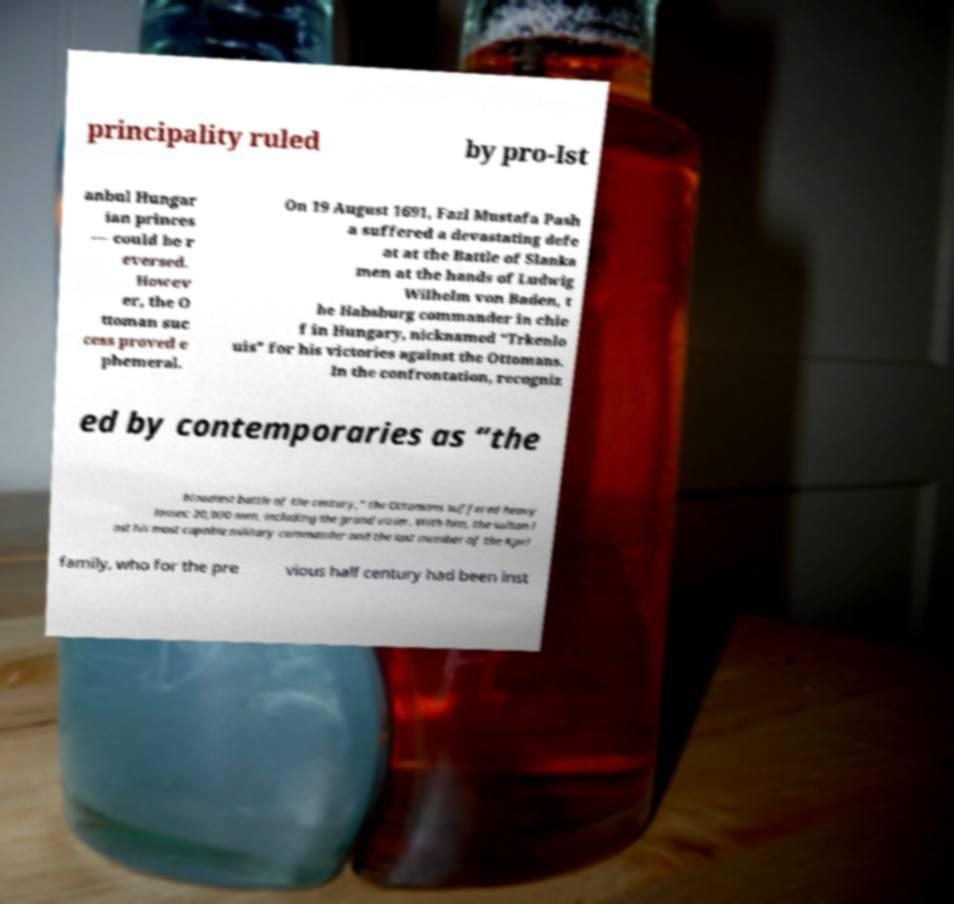For documentation purposes, I need the text within this image transcribed. Could you provide that? principality ruled by pro-Ist anbul Hungar ian princes — could be r eversed. Howev er, the O ttoman suc cess proved e phemeral. On 19 August 1691, Fazl Mustafa Pash a suffered a devastating defe at at the Battle of Slanka men at the hands of Ludwig Wilhelm von Baden, t he Habsburg commander in chie f in Hungary, nicknamed “Trkenlo uis” for his victories against the Ottomans. In the confrontation, recogniz ed by contemporaries as “the bloodiest battle of the century,” the Ottomans suffered heavy losses: 20,000 men, including the grand vizier. With him, the sultan l ost his most capable military commander and the last member of the Kprl family, who for the pre vious half century had been inst 